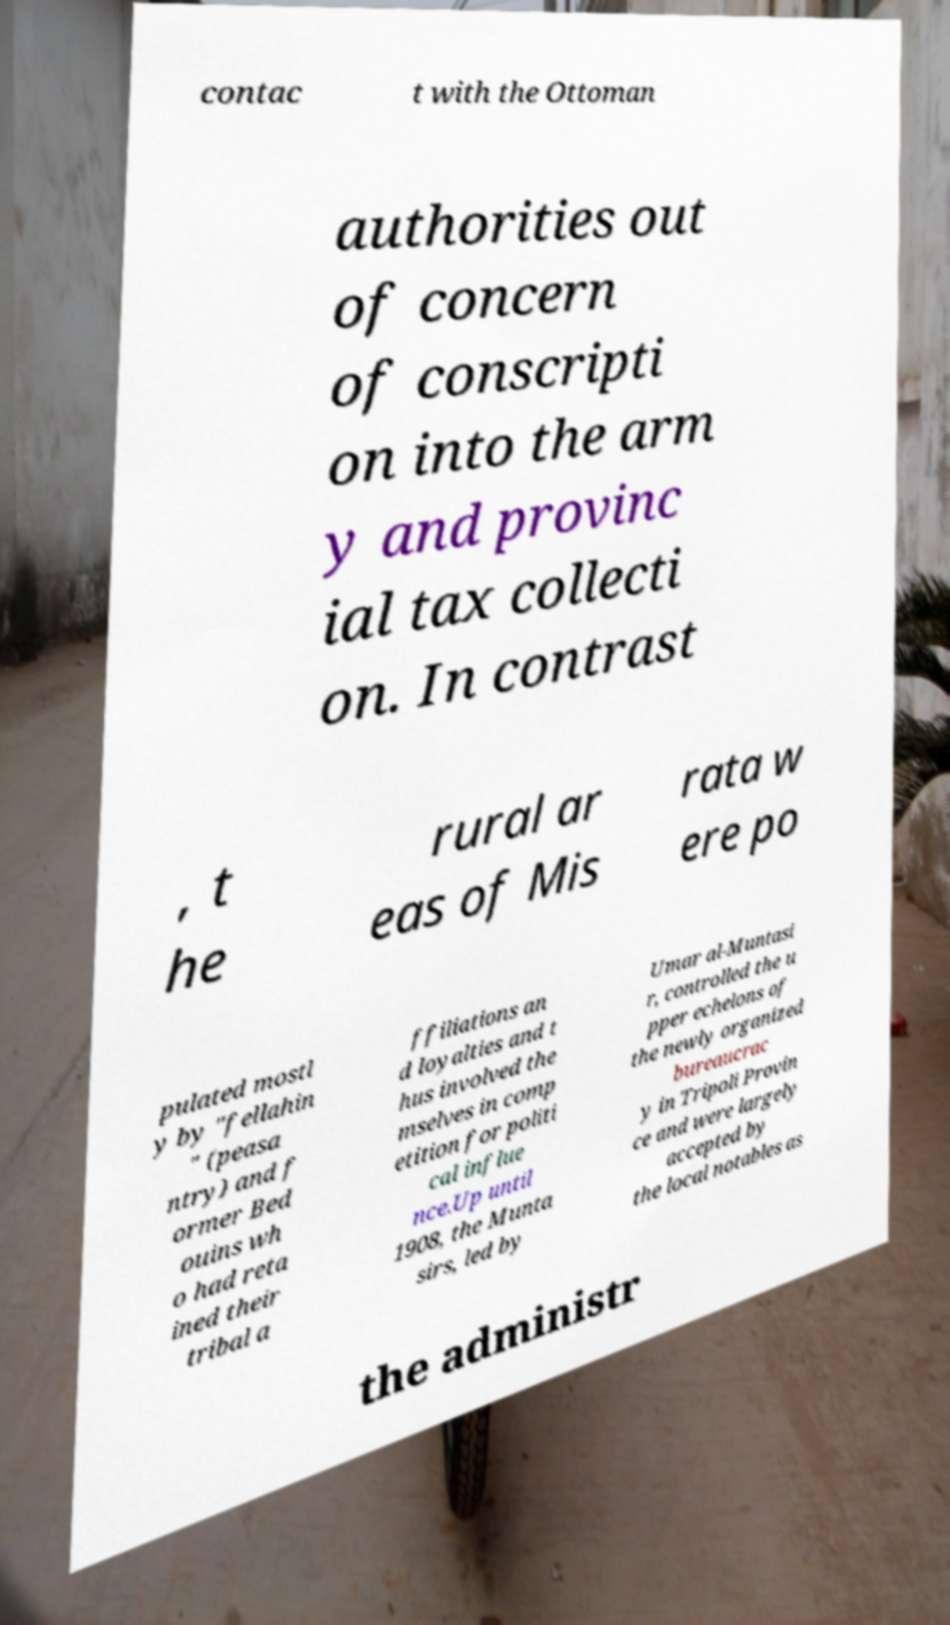Please identify and transcribe the text found in this image. contac t with the Ottoman authorities out of concern of conscripti on into the arm y and provinc ial tax collecti on. In contrast , t he rural ar eas of Mis rata w ere po pulated mostl y by "fellahin " (peasa ntry) and f ormer Bed ouins wh o had reta ined their tribal a ffiliations an d loyalties and t hus involved the mselves in comp etition for politi cal influe nce.Up until 1908, the Munta sirs, led by Umar al-Muntasi r, controlled the u pper echelons of the newly organized bureaucrac y in Tripoli Provin ce and were largely accepted by the local notables as the administr 